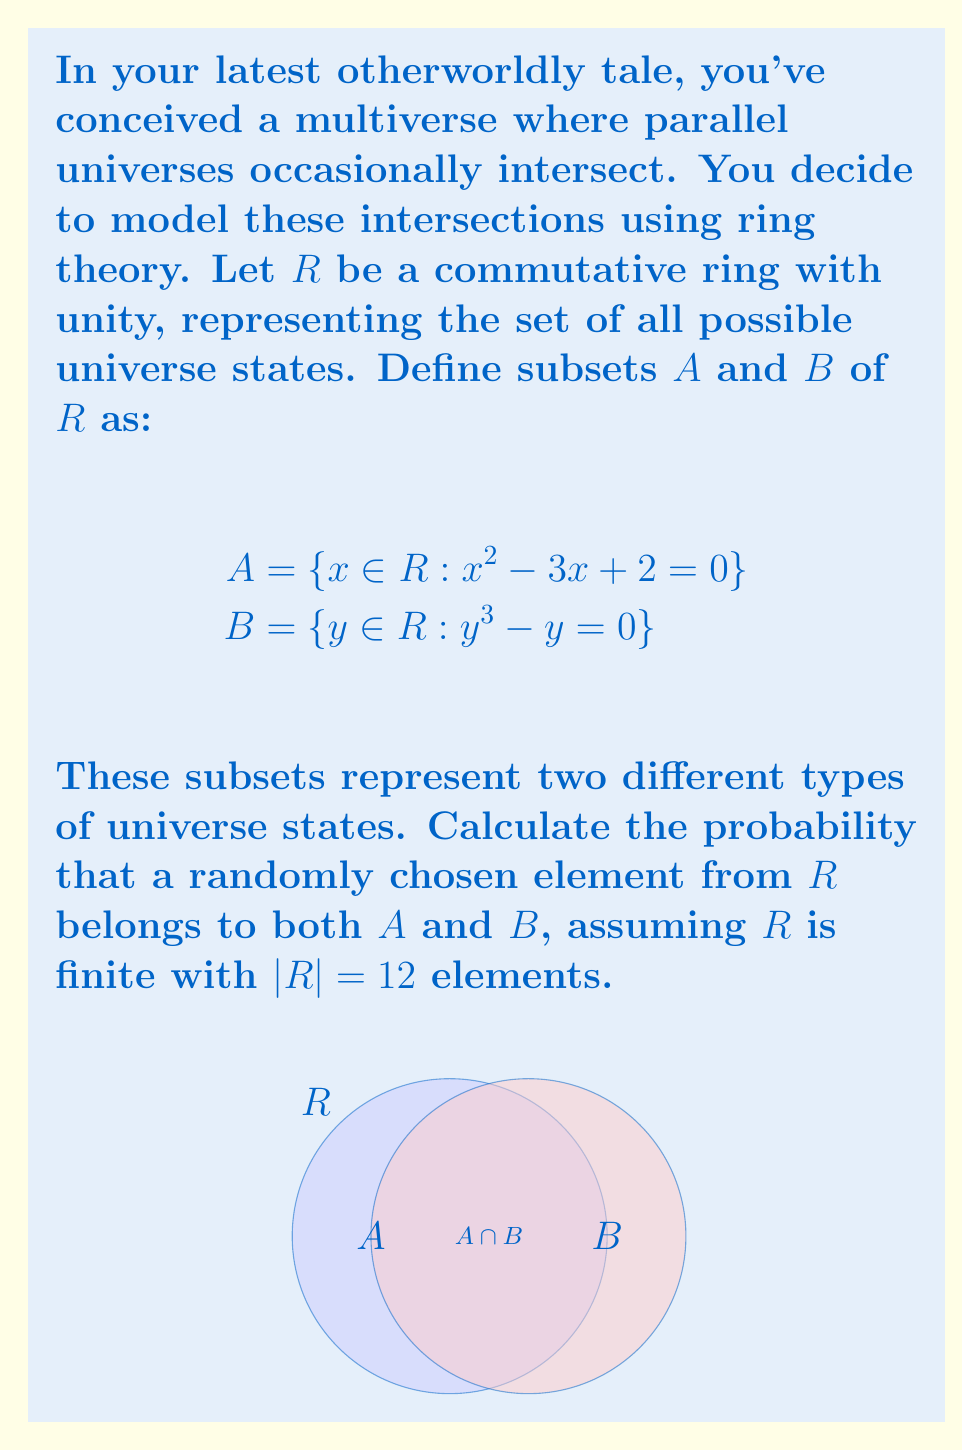What is the answer to this math problem? Let's approach this step-by-step:

1) First, we need to find the elements of $A$:
   $x^2 - 3x + 2 = 0$
   $(x - 1)(x - 2) = 0$
   So, $x = 1$ or $x = 2$
   Therefore, $A = \{1, 2\}$

2) Next, let's find the elements of $B$:
   $y^3 - y = 0$
   $y(y^2 - 1) = 0$
   $y(y + 1)(y - 1) = 0$
   So, $y = 0$, $y = 1$, or $y = -1$
   Therefore, $B = \{0, 1, -1\}$

3) Now, we need to find $A \cap B$:
   $A \cap B = \{1\}$

4) The probability is calculated as:
   $$P(A \cap B) = \frac{|A \cap B|}{|R|} = \frac{1}{12}$$

Where $|A \cap B|$ is the number of elements in the intersection of $A$ and $B$, and $|R|$ is the total number of elements in $R$.
Answer: $\frac{1}{12}$ 